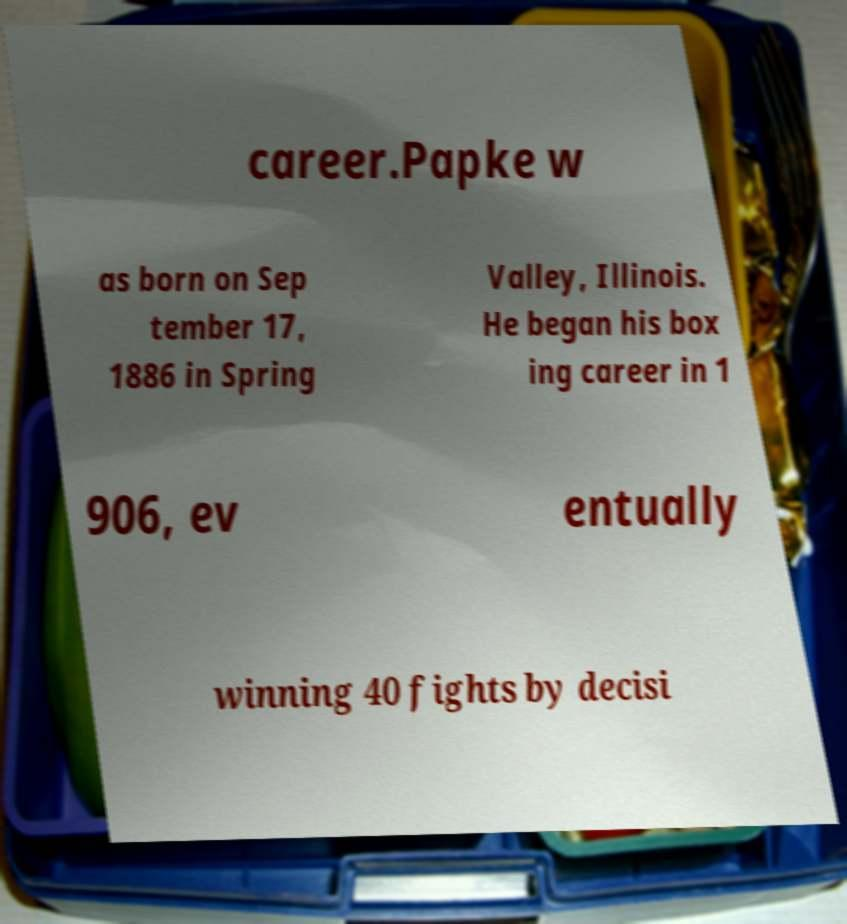Could you extract and type out the text from this image? career.Papke w as born on Sep tember 17, 1886 in Spring Valley, Illinois. He began his box ing career in 1 906, ev entually winning 40 fights by decisi 